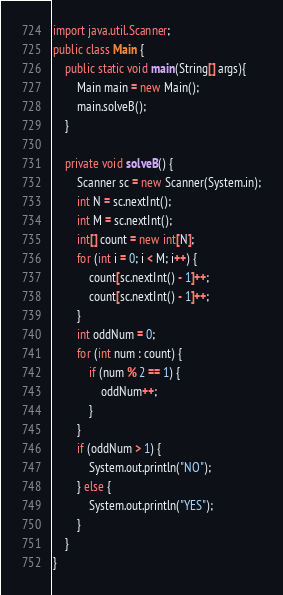Convert code to text. <code><loc_0><loc_0><loc_500><loc_500><_Java_>import java.util.Scanner;
public class Main {
	public static void main(String[] args){
		Main main = new Main();
		main.solveB();
	}

	private void solveB() {
		Scanner sc = new Scanner(System.in);
		int N = sc.nextInt();
		int M = sc.nextInt();
		int[] count = new int[N];
		for (int i = 0; i < M; i++) {
			count[sc.nextInt() - 1]++;
			count[sc.nextInt() - 1]++;
		}
		int oddNum = 0;
		for (int num : count) {
			if (num % 2 == 1) {
				oddNum++;
			}
		}
		if (oddNum > 1) {
			System.out.println("NO");
		} else {
			System.out.println("YES");
		}
	}
}</code> 